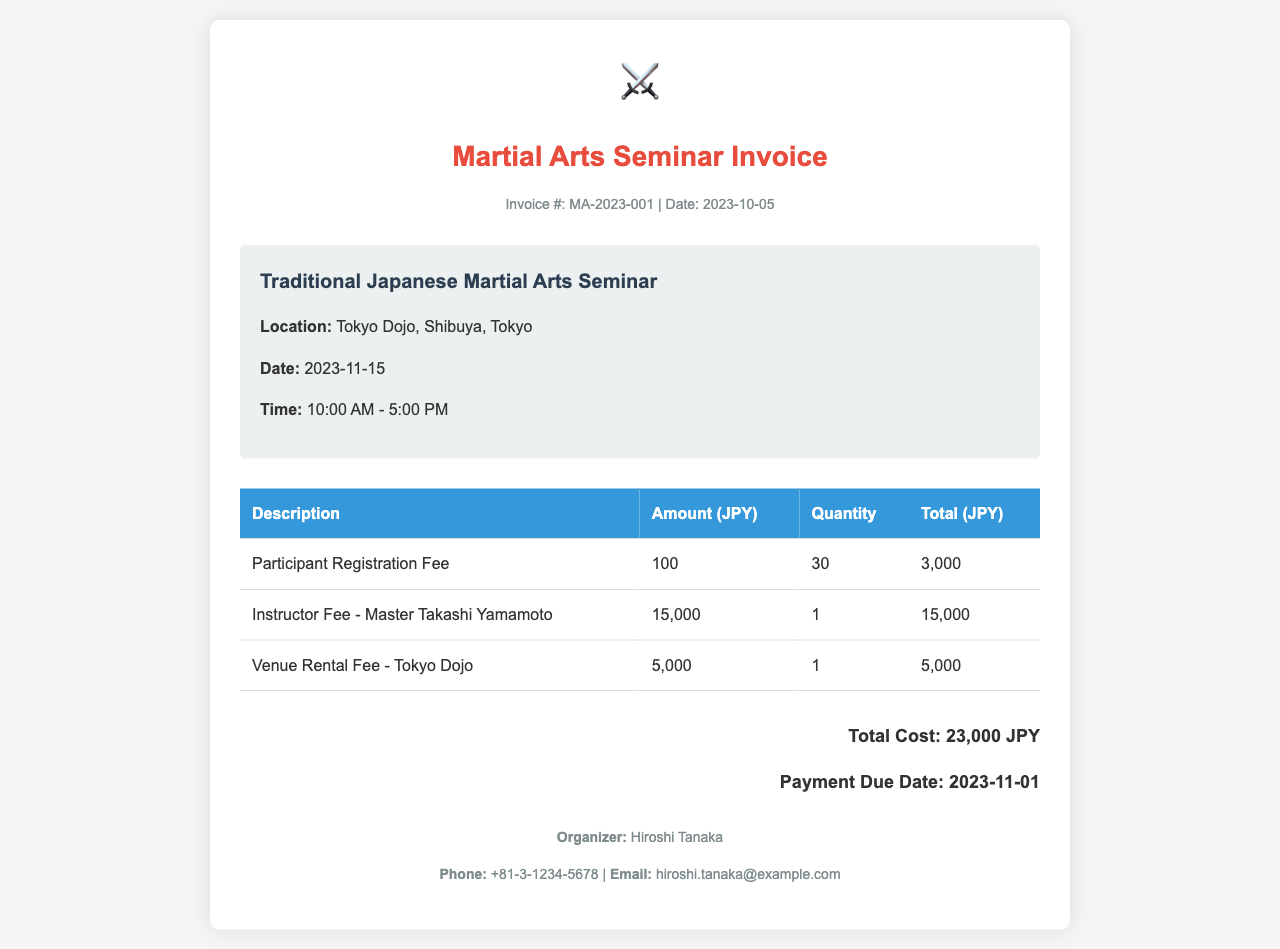What is the invoice number? The invoice number listed in the document is the unique identifier for the invoice.
Answer: MA-2023-001 What is the date of the seminar? This information is critical for participants to know when the event takes place.
Answer: 2023-11-15 Who is the instructor for the seminar? The instructor's name helps identify who will be leading the seminar, which is important for credibility.
Answer: Master Takashi Yamamoto What is the quantity of participants registered? This number indicates how many participants have signed up for the seminar, reflecting its popularity.
Answer: 30 What is the total cost of the seminar? The total cost summarizes all fees associated with the seminar, providing a quick financial overview.
Answer: 23,000 JPY What is the venue for the seminar? The venue is where the seminar will be held, which is important for attendees to locate the event.
Answer: Tokyo Dojo What is the payment due date? This date is essential for participants to know when they need to complete their payments.
Answer: 2023-11-01 How much is the instructor fee? Knowing the fee for the instructor helps understand the costs involved in hosting the seminar.
Answer: 15,000 What is the registration fee per participant? The registration fee gives an idea of the individual cost for attendees interested in joining the seminar.
Answer: 100 